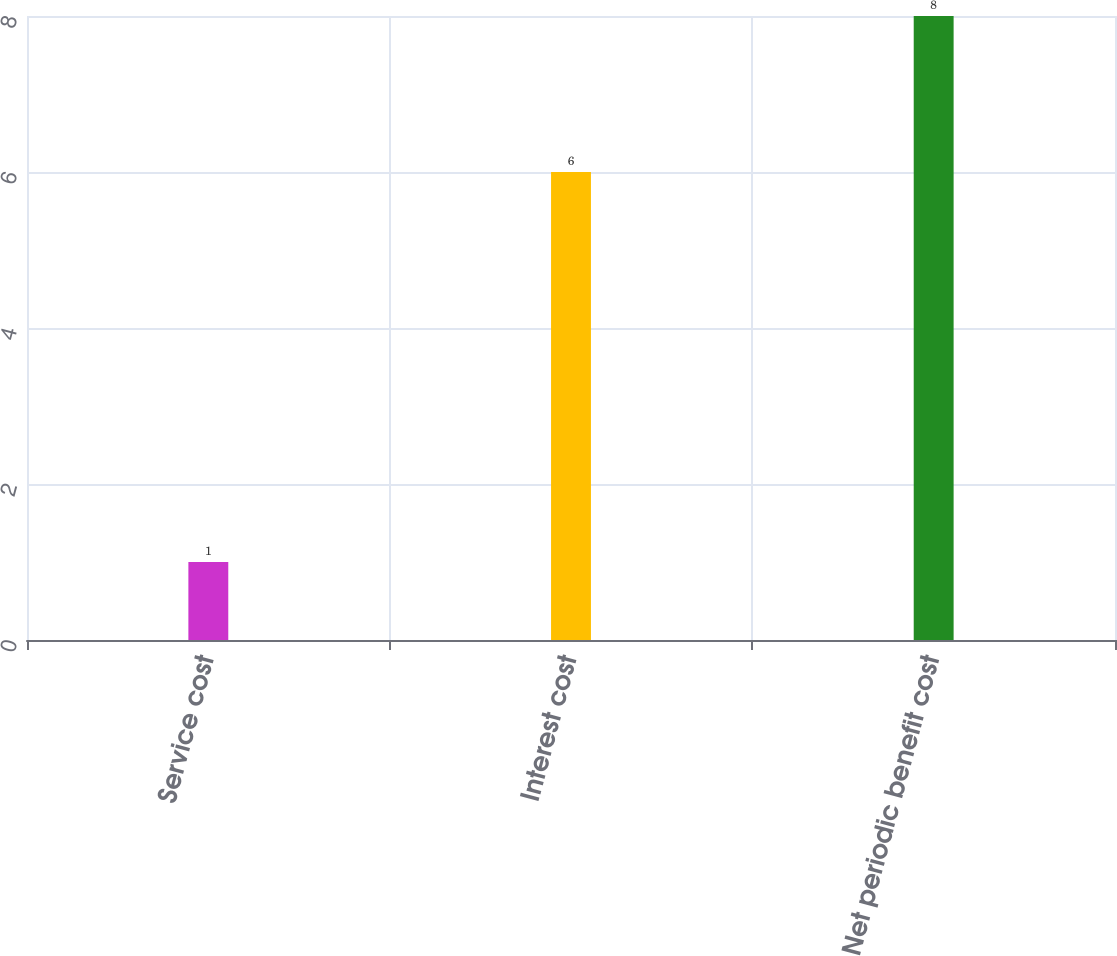Convert chart to OTSL. <chart><loc_0><loc_0><loc_500><loc_500><bar_chart><fcel>Service cost<fcel>Interest cost<fcel>Net periodic benefit cost<nl><fcel>1<fcel>6<fcel>8<nl></chart> 